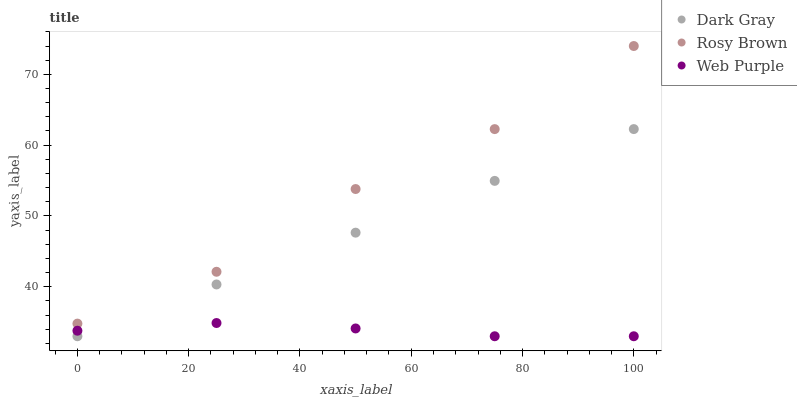Does Web Purple have the minimum area under the curve?
Answer yes or no. Yes. Does Rosy Brown have the maximum area under the curve?
Answer yes or no. Yes. Does Rosy Brown have the minimum area under the curve?
Answer yes or no. No. Does Web Purple have the maximum area under the curve?
Answer yes or no. No. Is Dark Gray the smoothest?
Answer yes or no. Yes. Is Rosy Brown the roughest?
Answer yes or no. Yes. Is Web Purple the smoothest?
Answer yes or no. No. Is Web Purple the roughest?
Answer yes or no. No. Does Dark Gray have the lowest value?
Answer yes or no. Yes. Does Rosy Brown have the lowest value?
Answer yes or no. No. Does Rosy Brown have the highest value?
Answer yes or no. Yes. Does Web Purple have the highest value?
Answer yes or no. No. Is Web Purple less than Rosy Brown?
Answer yes or no. Yes. Is Rosy Brown greater than Dark Gray?
Answer yes or no. Yes. Does Dark Gray intersect Web Purple?
Answer yes or no. Yes. Is Dark Gray less than Web Purple?
Answer yes or no. No. Is Dark Gray greater than Web Purple?
Answer yes or no. No. Does Web Purple intersect Rosy Brown?
Answer yes or no. No. 